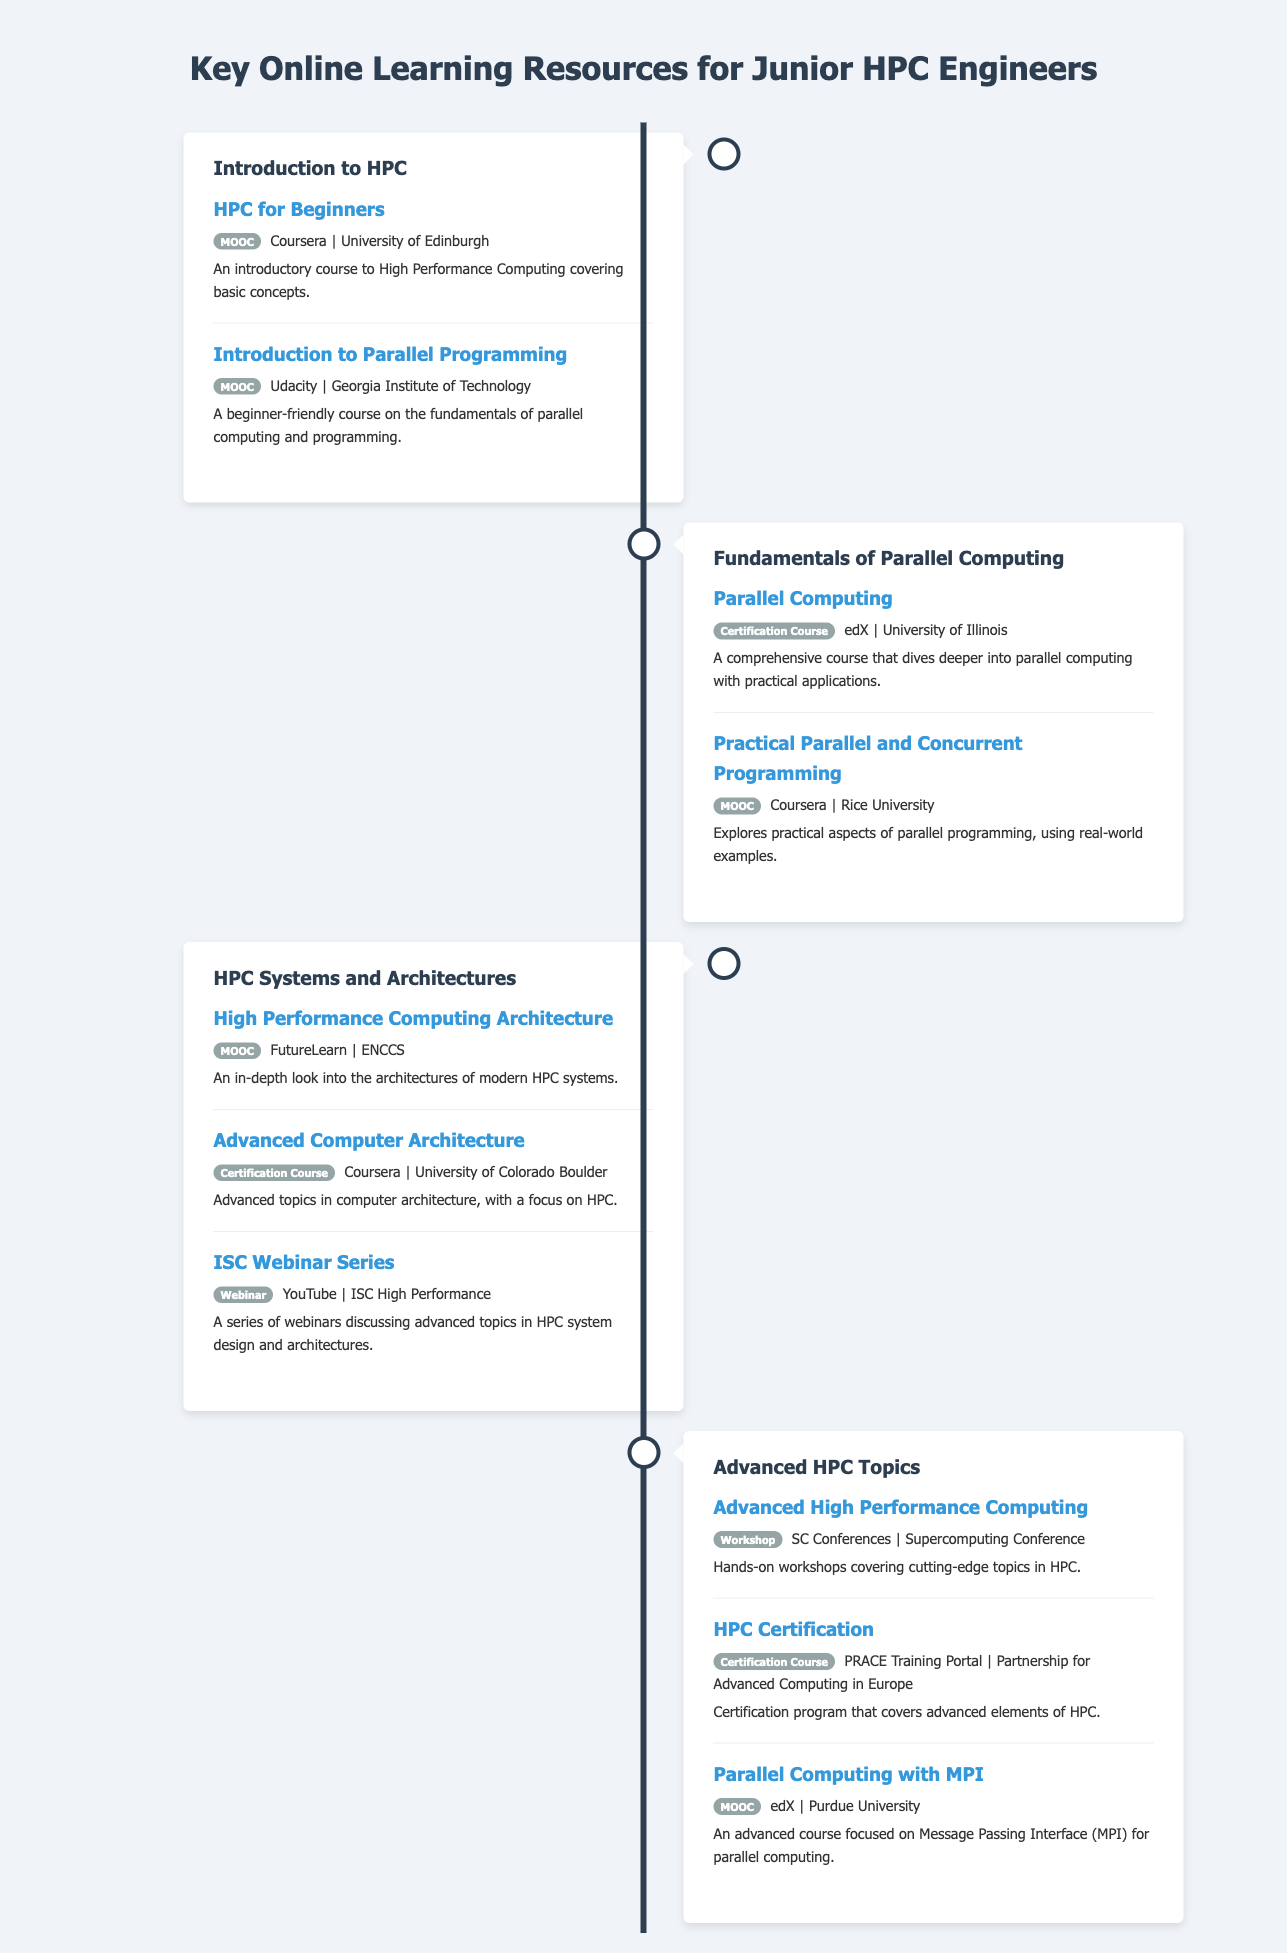what is the first course listed under "Introduction to HPC"? The first course under "Introduction to HPC" is "HPC for Beginners."
Answer: HPC for Beginners who offers the course "Advanced Computer Architecture"? The course "Advanced Computer Architecture" is offered by the University of Colorado Boulder.
Answer: University of Colorado Boulder how many resources are listed under "HPC Systems and Architectures"? There are three resources listed under "HPC Systems and Architectures."
Answer: Three what type of course is "Practical Parallel and Concurrent Programming"? "Practical Parallel and Concurrent Programming" is classified as a MOOC.
Answer: MOOC which resource is categorized as a workshop? The resource categorized as a workshop is "Advanced High Performance Computing."
Answer: Advanced High Performance Computing what is the last resource listed in the document? The last resource listed in the document is "Parallel Computing with MPI."
Answer: Parallel Computing with MPI what platform is the "HPC Certification" course associated with? The "HPC Certification" course is associated with the PRACE Training Portal.
Answer: PRACE Training Portal what is the main focus of the "ISC Webinar Series"? The main focus of the "ISC Webinar Series" is advanced topics in HPC system design and architectures.
Answer: advanced topics in HPC system design and architectures 